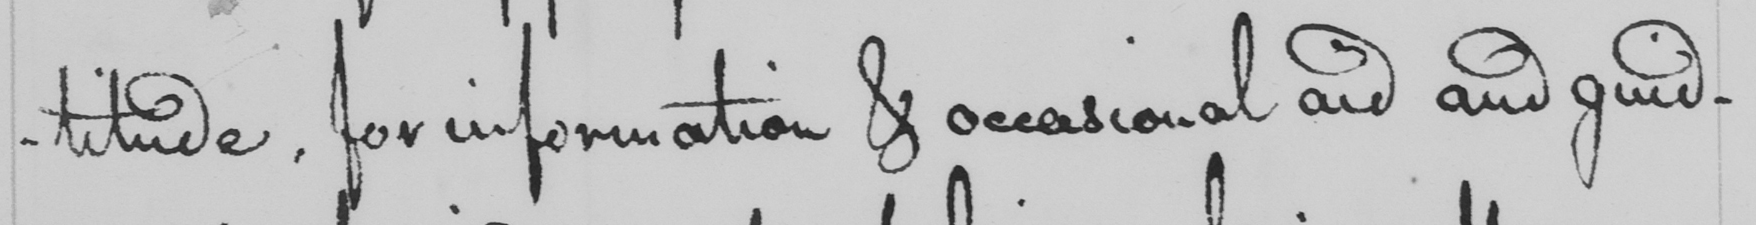Please provide the text content of this handwritten line. -titude , for information & occasional aid and guid- 